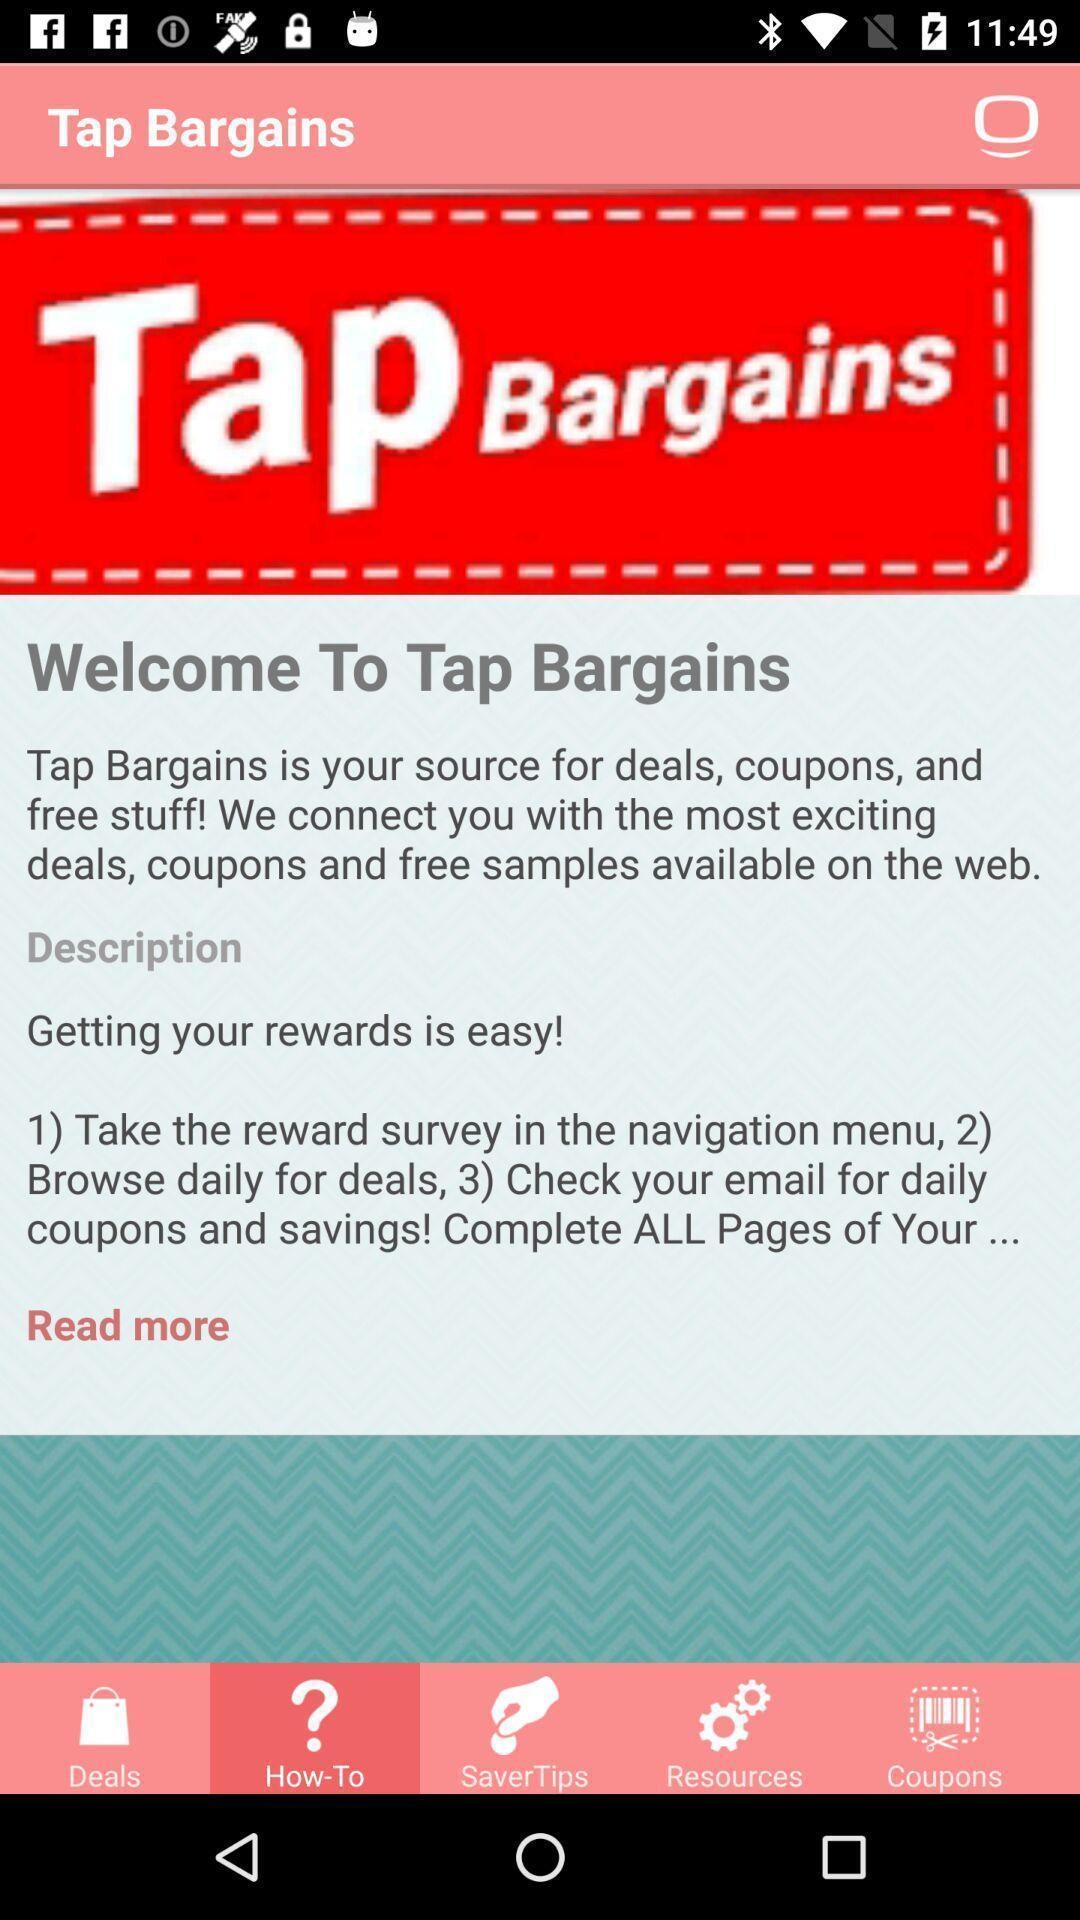Describe the visual elements of this screenshot. Welcome page. 